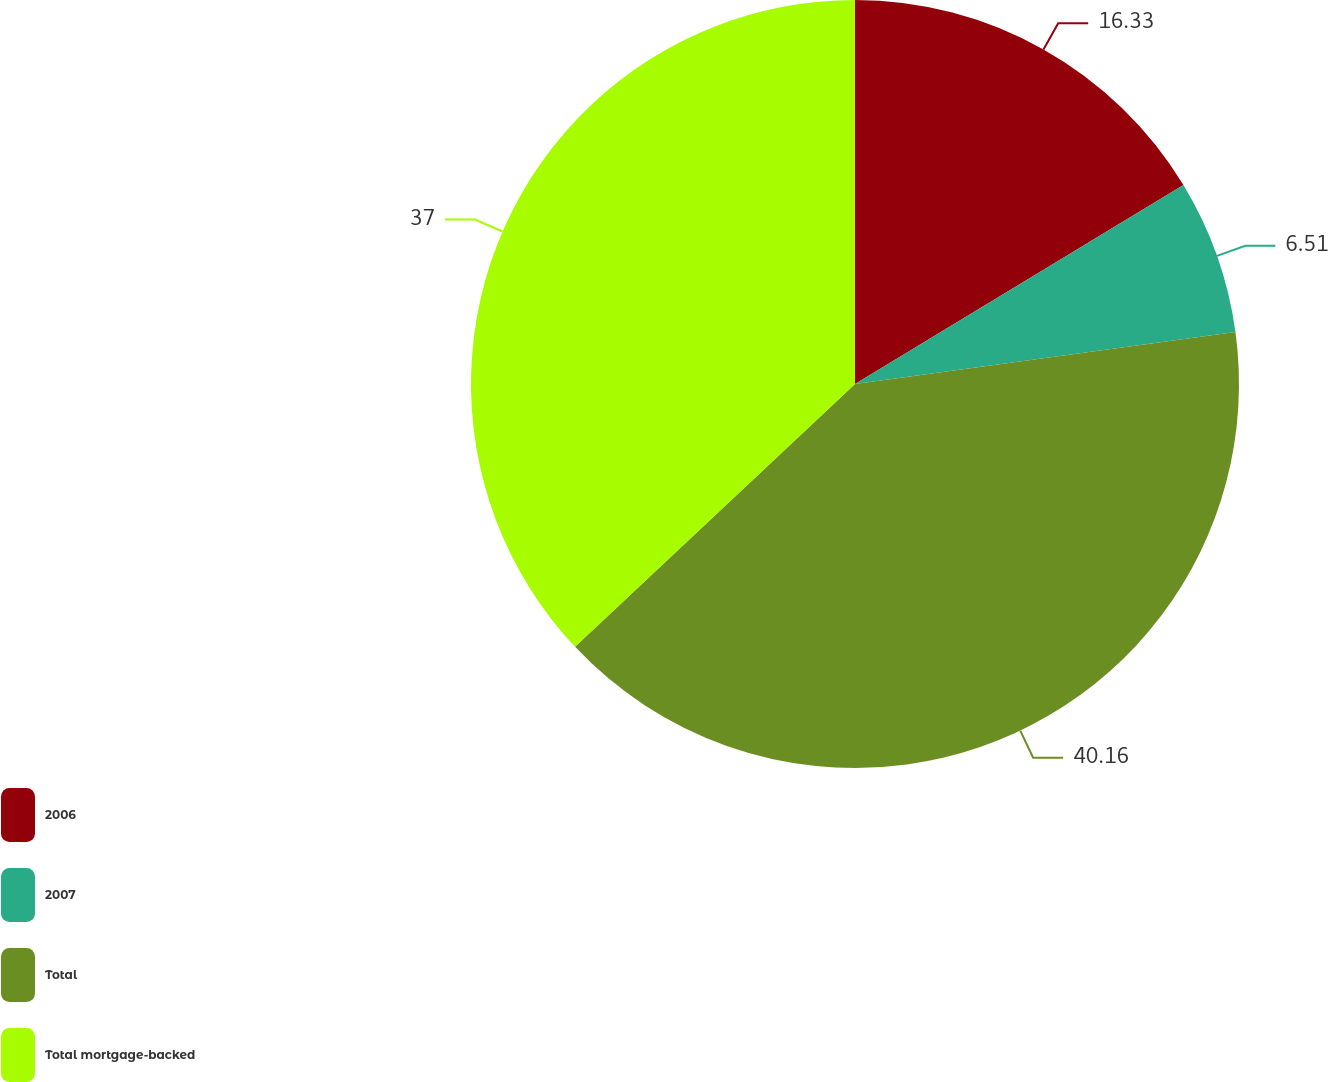Convert chart to OTSL. <chart><loc_0><loc_0><loc_500><loc_500><pie_chart><fcel>2006<fcel>2007<fcel>Total<fcel>Total mortgage-backed<nl><fcel>16.33%<fcel>6.51%<fcel>40.16%<fcel>37.0%<nl></chart> 